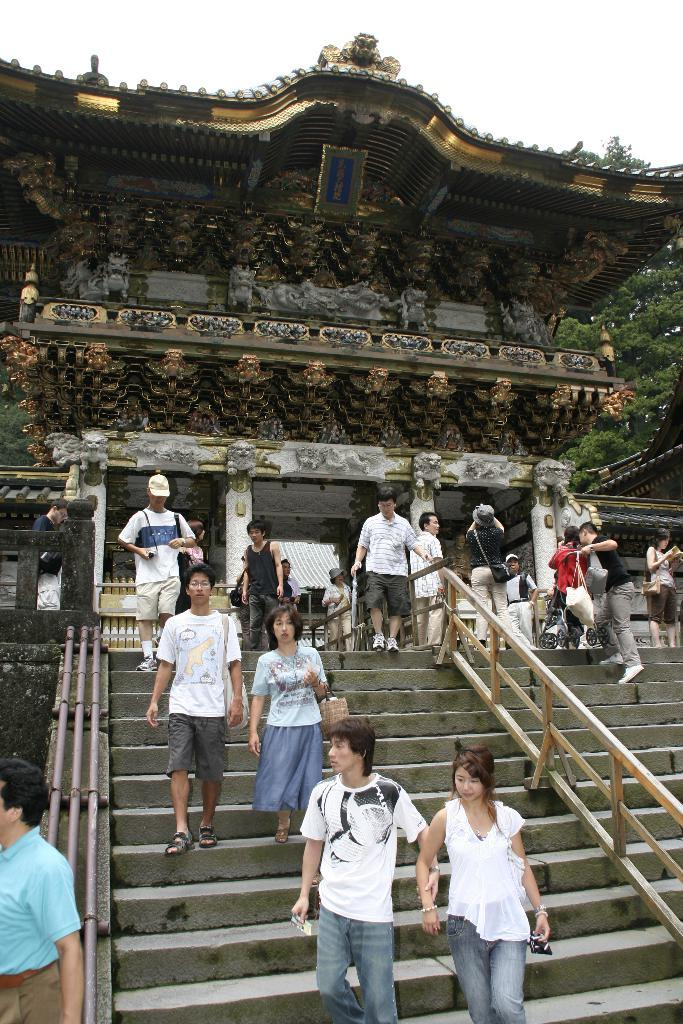What is the main structure in the picture? There is a temple in the picture. What is located in front of the temple? There are stairs in front of the temple. What are the people near the temple doing? The people are getting down the stairs. What can be seen on the right side of the image? There is a tree on the right side of the image. What type of beef is being served at the school in the image? There is no school or beef present in the image; it features a temple and people getting down the stairs. How many yams are visible on the tree in the image? There are no yams present in the image; it features a tree and a temple. 